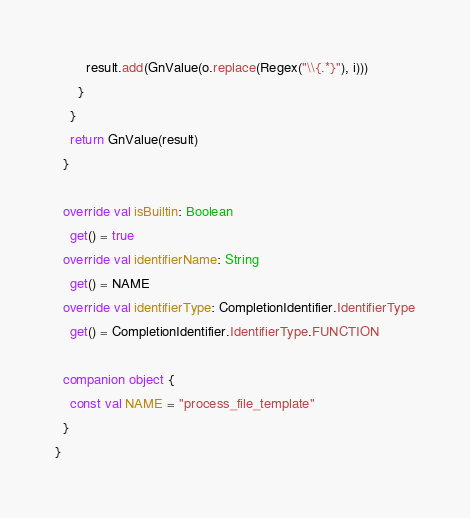<code> <loc_0><loc_0><loc_500><loc_500><_Kotlin_>        result.add(GnValue(o.replace(Regex("\\{.*}"), i)))
      }
    }
    return GnValue(result)
  }

  override val isBuiltin: Boolean
    get() = true
  override val identifierName: String
    get() = NAME
  override val identifierType: CompletionIdentifier.IdentifierType
    get() = CompletionIdentifier.IdentifierType.FUNCTION

  companion object {
    const val NAME = "process_file_template"
  }
}
</code> 